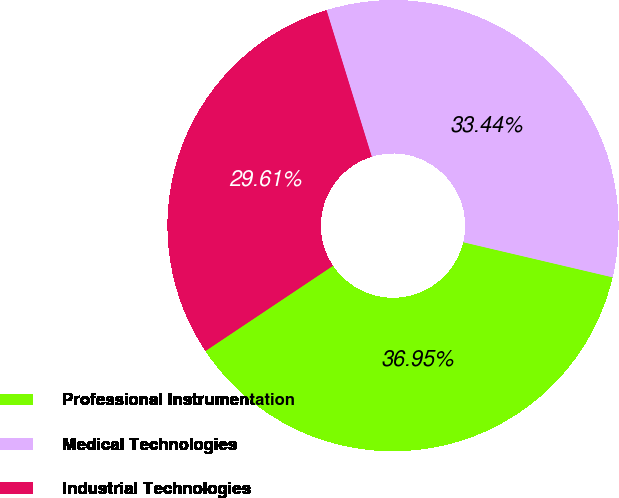<chart> <loc_0><loc_0><loc_500><loc_500><pie_chart><fcel>Professional Instrumentation<fcel>Medical Technologies<fcel>Industrial Technologies<nl><fcel>36.95%<fcel>33.44%<fcel>29.61%<nl></chart> 